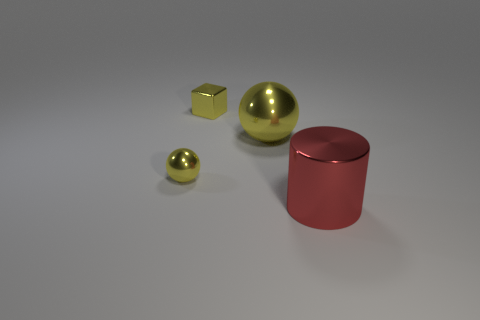How many metal objects are large green cylinders or small things?
Offer a terse response. 2. What color is the shiny sphere on the right side of the thing to the left of the cube?
Offer a terse response. Yellow. Is the small ball made of the same material as the large object that is on the left side of the red thing?
Keep it short and to the point. Yes. There is a large object that is left of the large metallic thing right of the large thing that is behind the big red shiny cylinder; what color is it?
Provide a succinct answer. Yellow. Is there anything else that is the same shape as the big red thing?
Ensure brevity in your answer.  No. Is the number of red objects greater than the number of big blue rubber spheres?
Provide a short and direct response. Yes. How many metallic things are behind the tiny metal ball and right of the small yellow cube?
Keep it short and to the point. 1. How many metal cylinders are behind the small object that is left of the small yellow block?
Ensure brevity in your answer.  0. Does the metallic object that is in front of the small ball have the same size as the yellow ball on the left side of the big yellow object?
Provide a succinct answer. No. How many metallic blocks are there?
Offer a terse response. 1. 